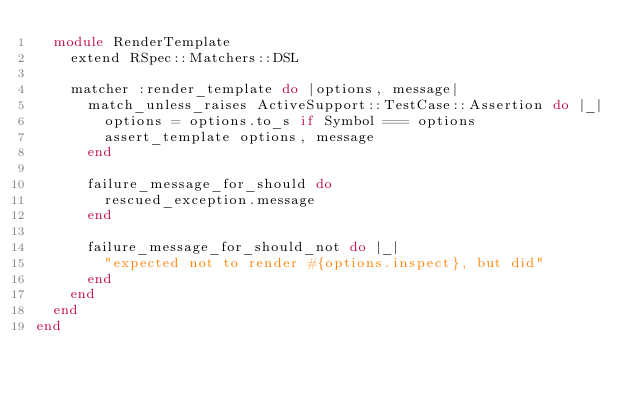Convert code to text. <code><loc_0><loc_0><loc_500><loc_500><_Ruby_>  module RenderTemplate
    extend RSpec::Matchers::DSL

    matcher :render_template do |options, message|
      match_unless_raises ActiveSupport::TestCase::Assertion do |_|
        options = options.to_s if Symbol === options
        assert_template options, message
      end

      failure_message_for_should do
        rescued_exception.message
      end

      failure_message_for_should_not do |_|
        "expected not to render #{options.inspect}, but did"
      end
    end
  end
end
</code> 